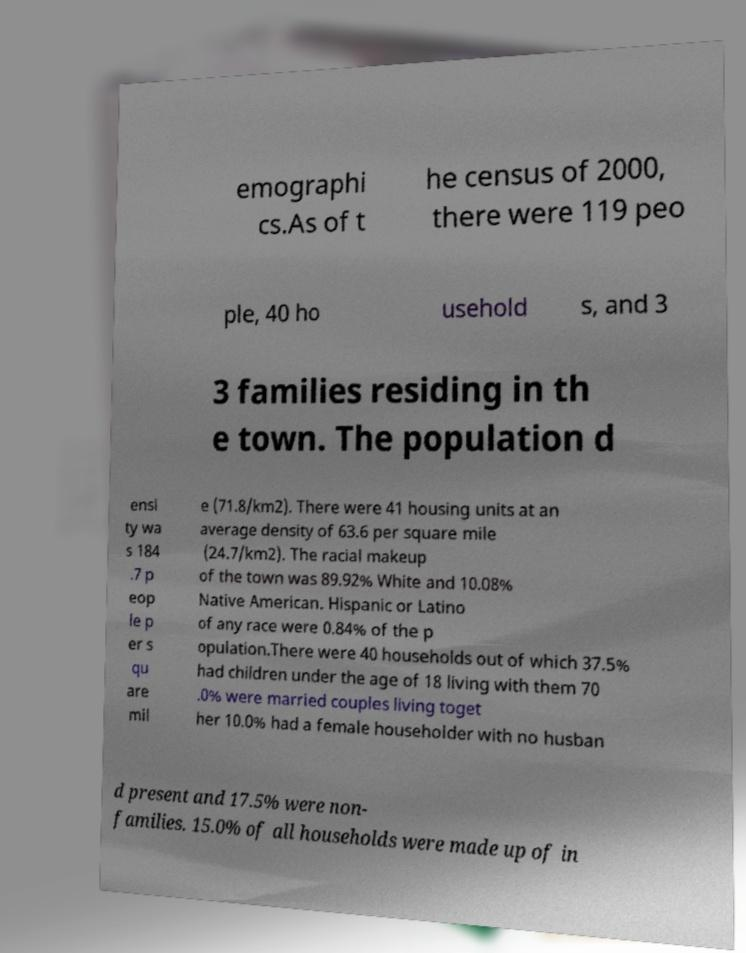For documentation purposes, I need the text within this image transcribed. Could you provide that? emographi cs.As of t he census of 2000, there were 119 peo ple, 40 ho usehold s, and 3 3 families residing in th e town. The population d ensi ty wa s 184 .7 p eop le p er s qu are mil e (71.8/km2). There were 41 housing units at an average density of 63.6 per square mile (24.7/km2). The racial makeup of the town was 89.92% White and 10.08% Native American. Hispanic or Latino of any race were 0.84% of the p opulation.There were 40 households out of which 37.5% had children under the age of 18 living with them 70 .0% were married couples living toget her 10.0% had a female householder with no husban d present and 17.5% were non- families. 15.0% of all households were made up of in 